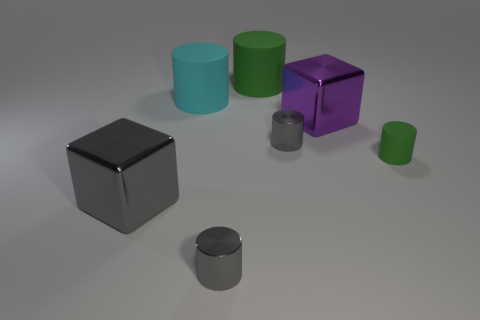Do the small rubber cylinder and the large cylinder behind the large cyan matte cylinder have the same color?
Your answer should be very brief. Yes. How many objects are either gray things that are on the right side of the large green cylinder or big metal things on the left side of the large green matte cylinder?
Make the answer very short. 2. Is the number of small cylinders in front of the large gray shiny cube greater than the number of purple things right of the tiny green object?
Your answer should be compact. Yes. What material is the gray cylinder that is left of the metallic cylinder behind the green matte object that is right of the purple metallic block?
Keep it short and to the point. Metal. Is the shape of the metallic thing that is in front of the large gray metallic block the same as the green matte object left of the purple metal cube?
Your response must be concise. Yes. Is there a gray cube that has the same size as the purple shiny block?
Provide a short and direct response. Yes. How many gray things are either shiny things or large matte cylinders?
Your answer should be very brief. 3. How many small metal cylinders are the same color as the tiny rubber cylinder?
Your answer should be compact. 0. How many blocks are either big matte things or purple things?
Your answer should be compact. 1. There is a large thing in front of the small rubber thing; what color is it?
Offer a terse response. Gray. 